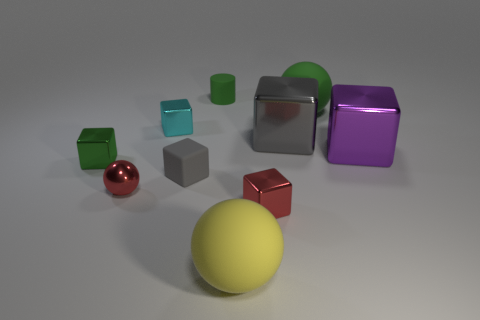Subtract 1 blocks. How many blocks are left? 5 Subtract all green blocks. How many blocks are left? 5 Subtract all tiny cyan blocks. How many blocks are left? 5 Subtract all yellow cubes. Subtract all red cylinders. How many cubes are left? 6 Subtract all cubes. How many objects are left? 4 Add 8 large purple cubes. How many large purple cubes exist? 9 Subtract 0 brown spheres. How many objects are left? 10 Subtract all red things. Subtract all large purple metallic things. How many objects are left? 7 Add 8 gray cubes. How many gray cubes are left? 10 